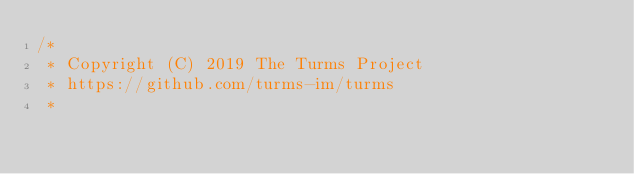Convert code to text. <code><loc_0><loc_0><loc_500><loc_500><_Java_>/*
 * Copyright (C) 2019 The Turms Project
 * https://github.com/turms-im/turms
 *</code> 